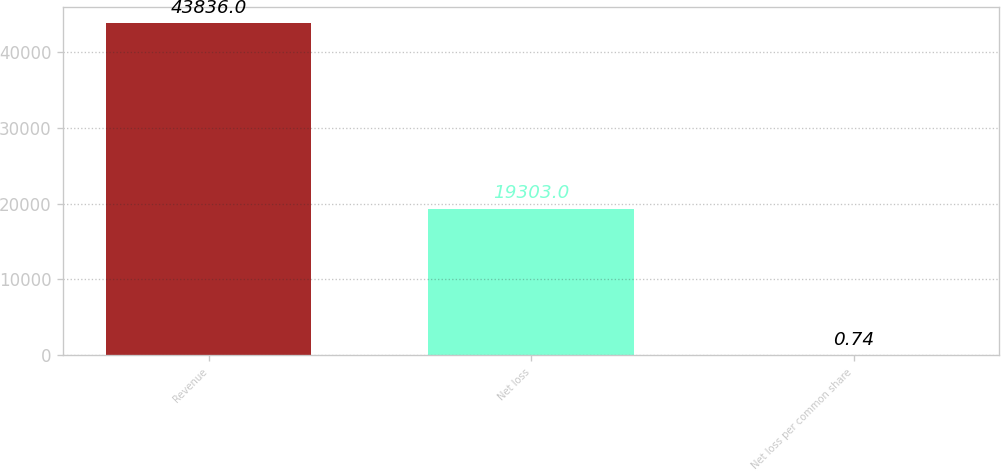Convert chart. <chart><loc_0><loc_0><loc_500><loc_500><bar_chart><fcel>Revenue<fcel>Net loss<fcel>Net loss per common share<nl><fcel>43836<fcel>19303<fcel>0.74<nl></chart> 